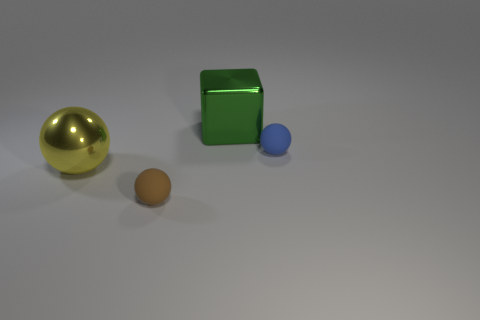Subtract 1 spheres. How many spheres are left? 2 Add 4 small blue shiny things. How many objects exist? 8 Subtract all spheres. How many objects are left? 1 Subtract all small gray rubber things. Subtract all brown matte objects. How many objects are left? 3 Add 2 balls. How many balls are left? 5 Add 2 large green cubes. How many large green cubes exist? 3 Subtract 0 cyan blocks. How many objects are left? 4 